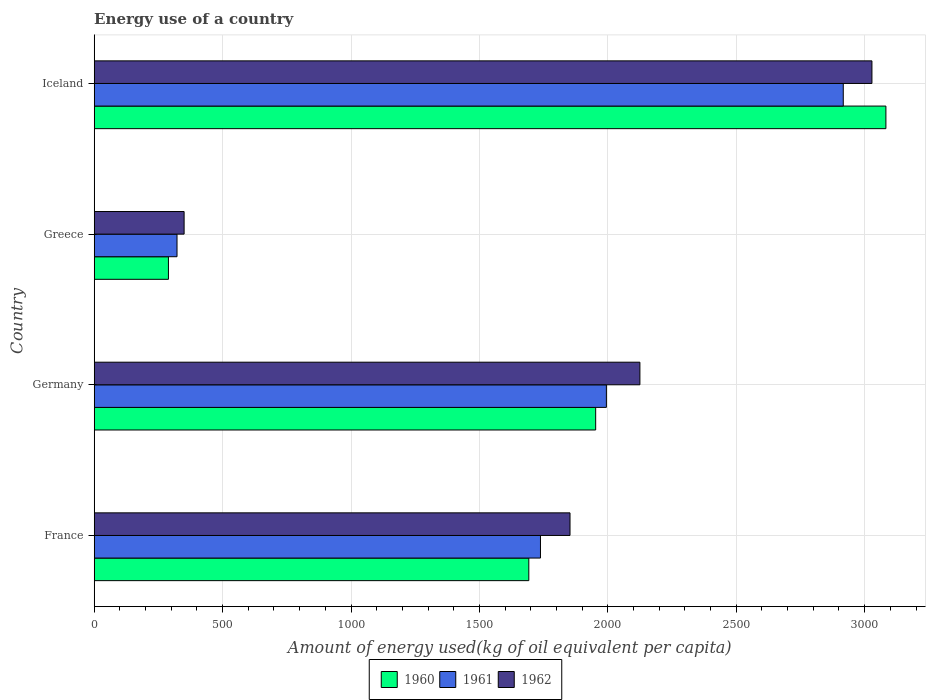How many bars are there on the 4th tick from the top?
Make the answer very short. 3. How many bars are there on the 4th tick from the bottom?
Give a very brief answer. 3. In how many cases, is the number of bars for a given country not equal to the number of legend labels?
Provide a short and direct response. 0. What is the amount of energy used in in 1960 in France?
Make the answer very short. 1692.26. Across all countries, what is the maximum amount of energy used in in 1960?
Provide a short and direct response. 3082.71. Across all countries, what is the minimum amount of energy used in in 1962?
Offer a terse response. 350.1. What is the total amount of energy used in in 1961 in the graph?
Offer a terse response. 6971.21. What is the difference between the amount of energy used in in 1962 in Germany and that in Iceland?
Offer a terse response. -903.45. What is the difference between the amount of energy used in in 1961 in Greece and the amount of energy used in in 1962 in France?
Keep it short and to the point. -1530.25. What is the average amount of energy used in in 1962 per country?
Your response must be concise. 1839. What is the difference between the amount of energy used in in 1960 and amount of energy used in in 1961 in Germany?
Offer a terse response. -41.74. What is the ratio of the amount of energy used in in 1962 in Germany to that in Iceland?
Your answer should be compact. 0.7. Is the amount of energy used in in 1960 in France less than that in Greece?
Provide a short and direct response. No. Is the difference between the amount of energy used in in 1960 in Germany and Greece greater than the difference between the amount of energy used in in 1961 in Germany and Greece?
Provide a short and direct response. No. What is the difference between the highest and the second highest amount of energy used in in 1960?
Your answer should be very brief. 1130.12. What is the difference between the highest and the lowest amount of energy used in in 1960?
Keep it short and to the point. 2793.65. In how many countries, is the amount of energy used in in 1962 greater than the average amount of energy used in in 1962 taken over all countries?
Offer a very short reply. 3. Is the sum of the amount of energy used in in 1961 in Germany and Greece greater than the maximum amount of energy used in in 1962 across all countries?
Your answer should be compact. No. Is it the case that in every country, the sum of the amount of energy used in in 1960 and amount of energy used in in 1961 is greater than the amount of energy used in in 1962?
Keep it short and to the point. Yes. How many countries are there in the graph?
Offer a very short reply. 4. What is the difference between two consecutive major ticks on the X-axis?
Offer a terse response. 500. Does the graph contain any zero values?
Your response must be concise. No. Where does the legend appear in the graph?
Give a very brief answer. Bottom center. How many legend labels are there?
Keep it short and to the point. 3. What is the title of the graph?
Offer a terse response. Energy use of a country. Does "1960" appear as one of the legend labels in the graph?
Your response must be concise. Yes. What is the label or title of the X-axis?
Provide a short and direct response. Amount of energy used(kg of oil equivalent per capita). What is the Amount of energy used(kg of oil equivalent per capita) in 1960 in France?
Provide a succinct answer. 1692.26. What is the Amount of energy used(kg of oil equivalent per capita) in 1961 in France?
Offer a very short reply. 1737.69. What is the Amount of energy used(kg of oil equivalent per capita) in 1962 in France?
Keep it short and to the point. 1852.74. What is the Amount of energy used(kg of oil equivalent per capita) of 1960 in Germany?
Provide a short and direct response. 1952.59. What is the Amount of energy used(kg of oil equivalent per capita) of 1961 in Germany?
Ensure brevity in your answer.  1994.32. What is the Amount of energy used(kg of oil equivalent per capita) in 1962 in Germany?
Your answer should be compact. 2124.85. What is the Amount of energy used(kg of oil equivalent per capita) of 1960 in Greece?
Provide a succinct answer. 289.06. What is the Amount of energy used(kg of oil equivalent per capita) of 1961 in Greece?
Your response must be concise. 322.49. What is the Amount of energy used(kg of oil equivalent per capita) in 1962 in Greece?
Your response must be concise. 350.1. What is the Amount of energy used(kg of oil equivalent per capita) of 1960 in Iceland?
Offer a terse response. 3082.71. What is the Amount of energy used(kg of oil equivalent per capita) of 1961 in Iceland?
Your response must be concise. 2916.71. What is the Amount of energy used(kg of oil equivalent per capita) in 1962 in Iceland?
Keep it short and to the point. 3028.3. Across all countries, what is the maximum Amount of energy used(kg of oil equivalent per capita) of 1960?
Keep it short and to the point. 3082.71. Across all countries, what is the maximum Amount of energy used(kg of oil equivalent per capita) in 1961?
Offer a very short reply. 2916.71. Across all countries, what is the maximum Amount of energy used(kg of oil equivalent per capita) of 1962?
Give a very brief answer. 3028.3. Across all countries, what is the minimum Amount of energy used(kg of oil equivalent per capita) in 1960?
Ensure brevity in your answer.  289.06. Across all countries, what is the minimum Amount of energy used(kg of oil equivalent per capita) in 1961?
Make the answer very short. 322.49. Across all countries, what is the minimum Amount of energy used(kg of oil equivalent per capita) of 1962?
Offer a terse response. 350.1. What is the total Amount of energy used(kg of oil equivalent per capita) of 1960 in the graph?
Offer a terse response. 7016.62. What is the total Amount of energy used(kg of oil equivalent per capita) in 1961 in the graph?
Ensure brevity in your answer.  6971.21. What is the total Amount of energy used(kg of oil equivalent per capita) of 1962 in the graph?
Ensure brevity in your answer.  7355.98. What is the difference between the Amount of energy used(kg of oil equivalent per capita) of 1960 in France and that in Germany?
Your answer should be compact. -260.33. What is the difference between the Amount of energy used(kg of oil equivalent per capita) in 1961 in France and that in Germany?
Ensure brevity in your answer.  -256.64. What is the difference between the Amount of energy used(kg of oil equivalent per capita) of 1962 in France and that in Germany?
Keep it short and to the point. -272.11. What is the difference between the Amount of energy used(kg of oil equivalent per capita) of 1960 in France and that in Greece?
Your response must be concise. 1403.2. What is the difference between the Amount of energy used(kg of oil equivalent per capita) in 1961 in France and that in Greece?
Offer a very short reply. 1415.2. What is the difference between the Amount of energy used(kg of oil equivalent per capita) of 1962 in France and that in Greece?
Keep it short and to the point. 1502.63. What is the difference between the Amount of energy used(kg of oil equivalent per capita) of 1960 in France and that in Iceland?
Your response must be concise. -1390.45. What is the difference between the Amount of energy used(kg of oil equivalent per capita) in 1961 in France and that in Iceland?
Your answer should be compact. -1179.02. What is the difference between the Amount of energy used(kg of oil equivalent per capita) of 1962 in France and that in Iceland?
Ensure brevity in your answer.  -1175.56. What is the difference between the Amount of energy used(kg of oil equivalent per capita) in 1960 in Germany and that in Greece?
Your answer should be very brief. 1663.53. What is the difference between the Amount of energy used(kg of oil equivalent per capita) in 1961 in Germany and that in Greece?
Offer a very short reply. 1671.83. What is the difference between the Amount of energy used(kg of oil equivalent per capita) of 1962 in Germany and that in Greece?
Your answer should be very brief. 1774.75. What is the difference between the Amount of energy used(kg of oil equivalent per capita) of 1960 in Germany and that in Iceland?
Your answer should be very brief. -1130.12. What is the difference between the Amount of energy used(kg of oil equivalent per capita) of 1961 in Germany and that in Iceland?
Keep it short and to the point. -922.38. What is the difference between the Amount of energy used(kg of oil equivalent per capita) in 1962 in Germany and that in Iceland?
Ensure brevity in your answer.  -903.45. What is the difference between the Amount of energy used(kg of oil equivalent per capita) in 1960 in Greece and that in Iceland?
Make the answer very short. -2793.65. What is the difference between the Amount of energy used(kg of oil equivalent per capita) in 1961 in Greece and that in Iceland?
Offer a terse response. -2594.22. What is the difference between the Amount of energy used(kg of oil equivalent per capita) of 1962 in Greece and that in Iceland?
Provide a short and direct response. -2678.2. What is the difference between the Amount of energy used(kg of oil equivalent per capita) of 1960 in France and the Amount of energy used(kg of oil equivalent per capita) of 1961 in Germany?
Ensure brevity in your answer.  -302.06. What is the difference between the Amount of energy used(kg of oil equivalent per capita) in 1960 in France and the Amount of energy used(kg of oil equivalent per capita) in 1962 in Germany?
Give a very brief answer. -432.59. What is the difference between the Amount of energy used(kg of oil equivalent per capita) in 1961 in France and the Amount of energy used(kg of oil equivalent per capita) in 1962 in Germany?
Make the answer very short. -387.16. What is the difference between the Amount of energy used(kg of oil equivalent per capita) of 1960 in France and the Amount of energy used(kg of oil equivalent per capita) of 1961 in Greece?
Provide a succinct answer. 1369.77. What is the difference between the Amount of energy used(kg of oil equivalent per capita) of 1960 in France and the Amount of energy used(kg of oil equivalent per capita) of 1962 in Greece?
Give a very brief answer. 1342.16. What is the difference between the Amount of energy used(kg of oil equivalent per capita) of 1961 in France and the Amount of energy used(kg of oil equivalent per capita) of 1962 in Greece?
Your answer should be compact. 1387.59. What is the difference between the Amount of energy used(kg of oil equivalent per capita) of 1960 in France and the Amount of energy used(kg of oil equivalent per capita) of 1961 in Iceland?
Provide a succinct answer. -1224.44. What is the difference between the Amount of energy used(kg of oil equivalent per capita) of 1960 in France and the Amount of energy used(kg of oil equivalent per capita) of 1962 in Iceland?
Provide a short and direct response. -1336.04. What is the difference between the Amount of energy used(kg of oil equivalent per capita) in 1961 in France and the Amount of energy used(kg of oil equivalent per capita) in 1962 in Iceland?
Your response must be concise. -1290.61. What is the difference between the Amount of energy used(kg of oil equivalent per capita) of 1960 in Germany and the Amount of energy used(kg of oil equivalent per capita) of 1961 in Greece?
Give a very brief answer. 1630.1. What is the difference between the Amount of energy used(kg of oil equivalent per capita) in 1960 in Germany and the Amount of energy used(kg of oil equivalent per capita) in 1962 in Greece?
Give a very brief answer. 1602.49. What is the difference between the Amount of energy used(kg of oil equivalent per capita) of 1961 in Germany and the Amount of energy used(kg of oil equivalent per capita) of 1962 in Greece?
Your response must be concise. 1644.22. What is the difference between the Amount of energy used(kg of oil equivalent per capita) of 1960 in Germany and the Amount of energy used(kg of oil equivalent per capita) of 1961 in Iceland?
Keep it short and to the point. -964.12. What is the difference between the Amount of energy used(kg of oil equivalent per capita) of 1960 in Germany and the Amount of energy used(kg of oil equivalent per capita) of 1962 in Iceland?
Your response must be concise. -1075.71. What is the difference between the Amount of energy used(kg of oil equivalent per capita) in 1961 in Germany and the Amount of energy used(kg of oil equivalent per capita) in 1962 in Iceland?
Your answer should be compact. -1033.97. What is the difference between the Amount of energy used(kg of oil equivalent per capita) in 1960 in Greece and the Amount of energy used(kg of oil equivalent per capita) in 1961 in Iceland?
Give a very brief answer. -2627.65. What is the difference between the Amount of energy used(kg of oil equivalent per capita) of 1960 in Greece and the Amount of energy used(kg of oil equivalent per capita) of 1962 in Iceland?
Offer a terse response. -2739.24. What is the difference between the Amount of energy used(kg of oil equivalent per capita) of 1961 in Greece and the Amount of energy used(kg of oil equivalent per capita) of 1962 in Iceland?
Give a very brief answer. -2705.81. What is the average Amount of energy used(kg of oil equivalent per capita) of 1960 per country?
Your response must be concise. 1754.15. What is the average Amount of energy used(kg of oil equivalent per capita) in 1961 per country?
Offer a terse response. 1742.8. What is the average Amount of energy used(kg of oil equivalent per capita) of 1962 per country?
Your answer should be compact. 1839. What is the difference between the Amount of energy used(kg of oil equivalent per capita) in 1960 and Amount of energy used(kg of oil equivalent per capita) in 1961 in France?
Ensure brevity in your answer.  -45.43. What is the difference between the Amount of energy used(kg of oil equivalent per capita) of 1960 and Amount of energy used(kg of oil equivalent per capita) of 1962 in France?
Offer a terse response. -160.47. What is the difference between the Amount of energy used(kg of oil equivalent per capita) of 1961 and Amount of energy used(kg of oil equivalent per capita) of 1962 in France?
Give a very brief answer. -115.05. What is the difference between the Amount of energy used(kg of oil equivalent per capita) in 1960 and Amount of energy used(kg of oil equivalent per capita) in 1961 in Germany?
Your answer should be compact. -41.74. What is the difference between the Amount of energy used(kg of oil equivalent per capita) of 1960 and Amount of energy used(kg of oil equivalent per capita) of 1962 in Germany?
Keep it short and to the point. -172.26. What is the difference between the Amount of energy used(kg of oil equivalent per capita) of 1961 and Amount of energy used(kg of oil equivalent per capita) of 1962 in Germany?
Provide a short and direct response. -130.52. What is the difference between the Amount of energy used(kg of oil equivalent per capita) in 1960 and Amount of energy used(kg of oil equivalent per capita) in 1961 in Greece?
Your answer should be very brief. -33.43. What is the difference between the Amount of energy used(kg of oil equivalent per capita) in 1960 and Amount of energy used(kg of oil equivalent per capita) in 1962 in Greece?
Offer a terse response. -61.04. What is the difference between the Amount of energy used(kg of oil equivalent per capita) in 1961 and Amount of energy used(kg of oil equivalent per capita) in 1962 in Greece?
Your answer should be compact. -27.61. What is the difference between the Amount of energy used(kg of oil equivalent per capita) of 1960 and Amount of energy used(kg of oil equivalent per capita) of 1961 in Iceland?
Your response must be concise. 166.01. What is the difference between the Amount of energy used(kg of oil equivalent per capita) in 1960 and Amount of energy used(kg of oil equivalent per capita) in 1962 in Iceland?
Your response must be concise. 54.41. What is the difference between the Amount of energy used(kg of oil equivalent per capita) in 1961 and Amount of energy used(kg of oil equivalent per capita) in 1962 in Iceland?
Provide a short and direct response. -111.59. What is the ratio of the Amount of energy used(kg of oil equivalent per capita) in 1960 in France to that in Germany?
Offer a very short reply. 0.87. What is the ratio of the Amount of energy used(kg of oil equivalent per capita) in 1961 in France to that in Germany?
Provide a short and direct response. 0.87. What is the ratio of the Amount of energy used(kg of oil equivalent per capita) of 1962 in France to that in Germany?
Your response must be concise. 0.87. What is the ratio of the Amount of energy used(kg of oil equivalent per capita) of 1960 in France to that in Greece?
Provide a succinct answer. 5.85. What is the ratio of the Amount of energy used(kg of oil equivalent per capita) in 1961 in France to that in Greece?
Make the answer very short. 5.39. What is the ratio of the Amount of energy used(kg of oil equivalent per capita) in 1962 in France to that in Greece?
Offer a terse response. 5.29. What is the ratio of the Amount of energy used(kg of oil equivalent per capita) in 1960 in France to that in Iceland?
Give a very brief answer. 0.55. What is the ratio of the Amount of energy used(kg of oil equivalent per capita) in 1961 in France to that in Iceland?
Ensure brevity in your answer.  0.6. What is the ratio of the Amount of energy used(kg of oil equivalent per capita) in 1962 in France to that in Iceland?
Keep it short and to the point. 0.61. What is the ratio of the Amount of energy used(kg of oil equivalent per capita) of 1960 in Germany to that in Greece?
Ensure brevity in your answer.  6.75. What is the ratio of the Amount of energy used(kg of oil equivalent per capita) of 1961 in Germany to that in Greece?
Offer a very short reply. 6.18. What is the ratio of the Amount of energy used(kg of oil equivalent per capita) in 1962 in Germany to that in Greece?
Your answer should be compact. 6.07. What is the ratio of the Amount of energy used(kg of oil equivalent per capita) in 1960 in Germany to that in Iceland?
Your answer should be compact. 0.63. What is the ratio of the Amount of energy used(kg of oil equivalent per capita) in 1961 in Germany to that in Iceland?
Your response must be concise. 0.68. What is the ratio of the Amount of energy used(kg of oil equivalent per capita) in 1962 in Germany to that in Iceland?
Provide a succinct answer. 0.7. What is the ratio of the Amount of energy used(kg of oil equivalent per capita) of 1960 in Greece to that in Iceland?
Provide a short and direct response. 0.09. What is the ratio of the Amount of energy used(kg of oil equivalent per capita) in 1961 in Greece to that in Iceland?
Ensure brevity in your answer.  0.11. What is the ratio of the Amount of energy used(kg of oil equivalent per capita) in 1962 in Greece to that in Iceland?
Provide a succinct answer. 0.12. What is the difference between the highest and the second highest Amount of energy used(kg of oil equivalent per capita) of 1960?
Your response must be concise. 1130.12. What is the difference between the highest and the second highest Amount of energy used(kg of oil equivalent per capita) in 1961?
Your response must be concise. 922.38. What is the difference between the highest and the second highest Amount of energy used(kg of oil equivalent per capita) in 1962?
Provide a succinct answer. 903.45. What is the difference between the highest and the lowest Amount of energy used(kg of oil equivalent per capita) of 1960?
Your answer should be very brief. 2793.65. What is the difference between the highest and the lowest Amount of energy used(kg of oil equivalent per capita) of 1961?
Give a very brief answer. 2594.22. What is the difference between the highest and the lowest Amount of energy used(kg of oil equivalent per capita) in 1962?
Give a very brief answer. 2678.2. 